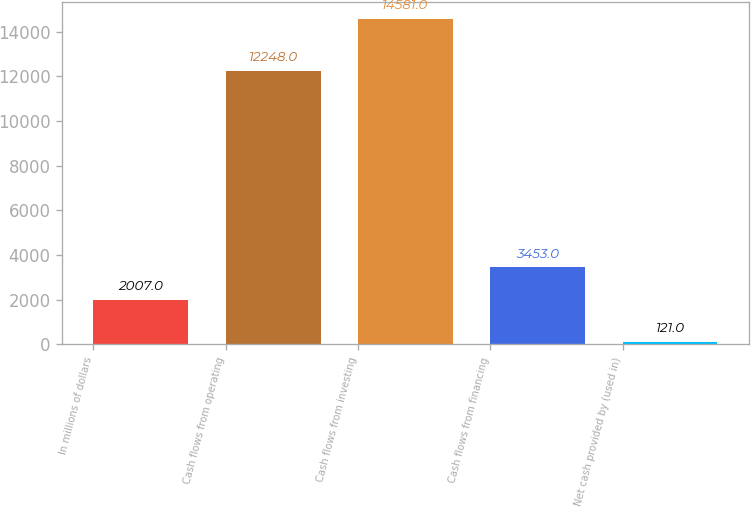Convert chart. <chart><loc_0><loc_0><loc_500><loc_500><bar_chart><fcel>In millions of dollars<fcel>Cash flows from operating<fcel>Cash flows from investing<fcel>Cash flows from financing<fcel>Net cash provided by (used in)<nl><fcel>2007<fcel>12248<fcel>14581<fcel>3453<fcel>121<nl></chart> 